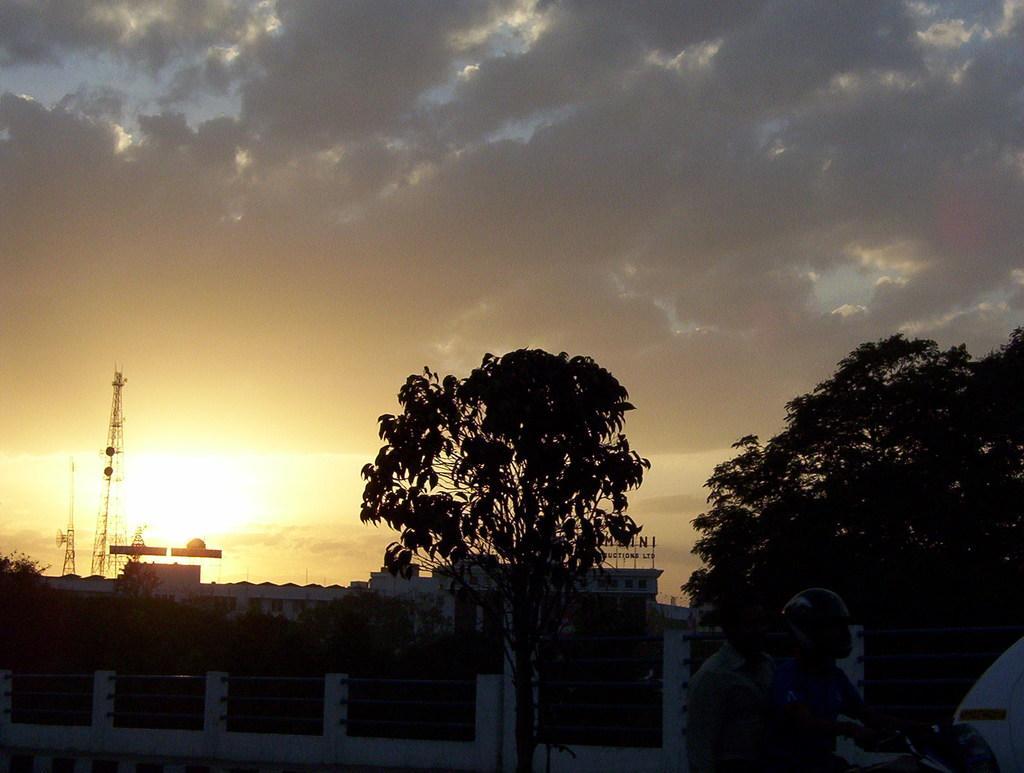Describe this image in one or two sentences. There is a railing with poles. Two persons are on motorcycle. One person is wearing a helmet. In the back there are trees, buildings, towers and sky with clouds. 